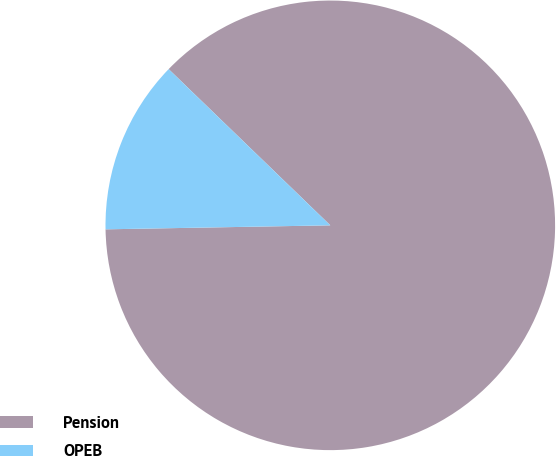Convert chart to OTSL. <chart><loc_0><loc_0><loc_500><loc_500><pie_chart><fcel>Pension<fcel>OPEB<nl><fcel>87.49%<fcel>12.51%<nl></chart> 